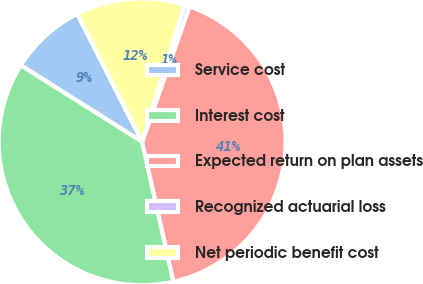Convert chart to OTSL. <chart><loc_0><loc_0><loc_500><loc_500><pie_chart><fcel>Service cost<fcel>Interest cost<fcel>Expected return on plan assets<fcel>Recognized actuarial loss<fcel>Net periodic benefit cost<nl><fcel>8.58%<fcel>37.45%<fcel>41.14%<fcel>0.57%<fcel>12.26%<nl></chart> 